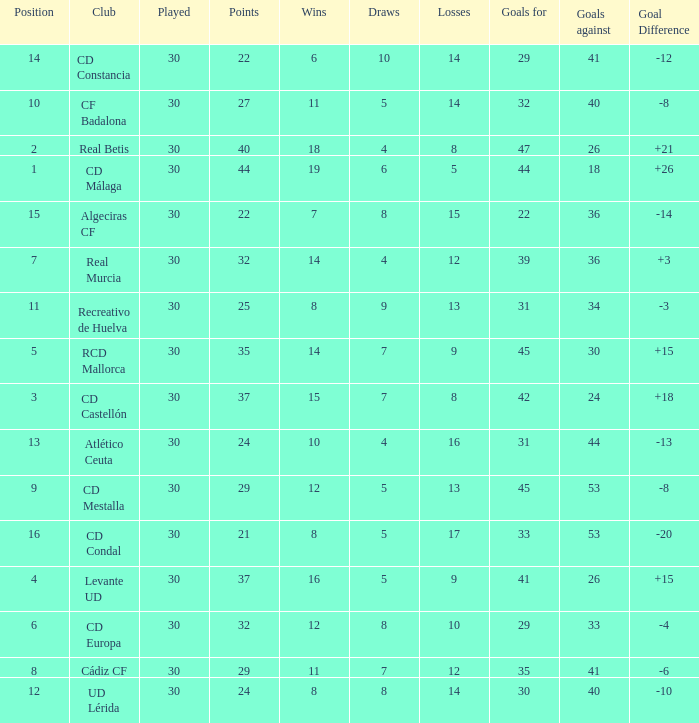What is the losses when the goal difference is larger than 26? None. 